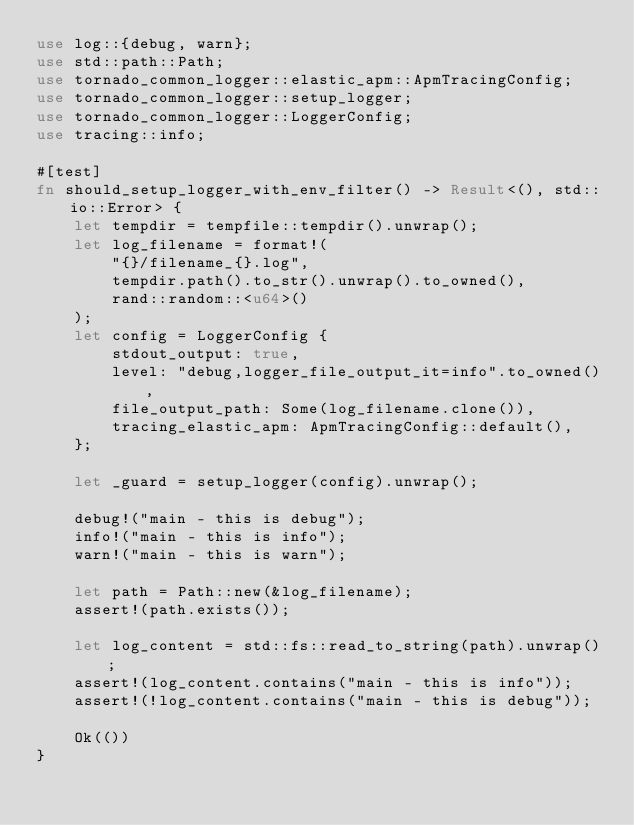Convert code to text. <code><loc_0><loc_0><loc_500><loc_500><_Rust_>use log::{debug, warn};
use std::path::Path;
use tornado_common_logger::elastic_apm::ApmTracingConfig;
use tornado_common_logger::setup_logger;
use tornado_common_logger::LoggerConfig;
use tracing::info;

#[test]
fn should_setup_logger_with_env_filter() -> Result<(), std::io::Error> {
    let tempdir = tempfile::tempdir().unwrap();
    let log_filename = format!(
        "{}/filename_{}.log",
        tempdir.path().to_str().unwrap().to_owned(),
        rand::random::<u64>()
    );
    let config = LoggerConfig {
        stdout_output: true,
        level: "debug,logger_file_output_it=info".to_owned(),
        file_output_path: Some(log_filename.clone()),
        tracing_elastic_apm: ApmTracingConfig::default(),
    };

    let _guard = setup_logger(config).unwrap();

    debug!("main - this is debug");
    info!("main - this is info");
    warn!("main - this is warn");

    let path = Path::new(&log_filename);
    assert!(path.exists());

    let log_content = std::fs::read_to_string(path).unwrap();
    assert!(log_content.contains("main - this is info"));
    assert!(!log_content.contains("main - this is debug"));

    Ok(())
}
</code> 